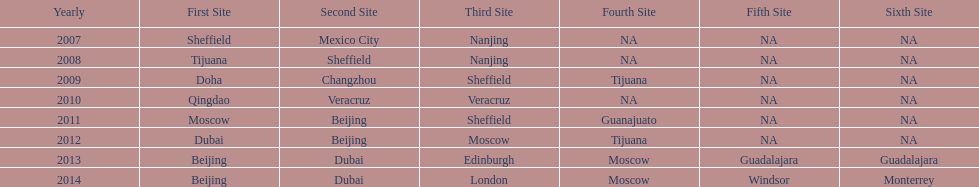How long, in years, has the this world series been occurring? 7 years. 